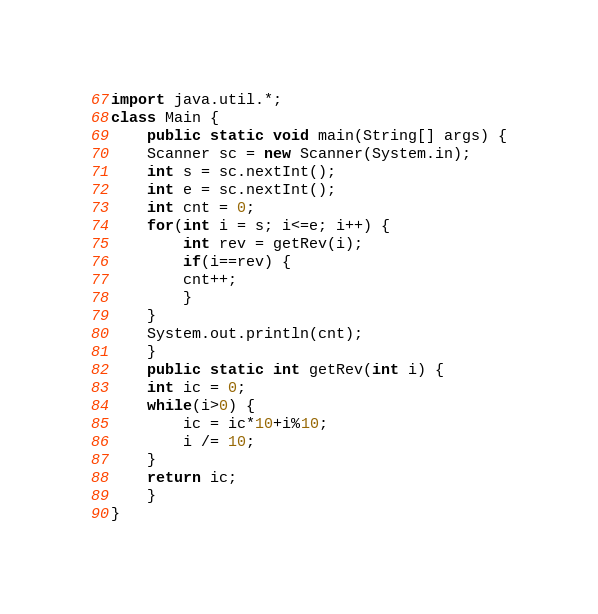Convert code to text. <code><loc_0><loc_0><loc_500><loc_500><_Java_>import java.util.*;
class Main {
    public static void main(String[] args) {
	Scanner sc = new Scanner(System.in);
	int s = sc.nextInt();
	int e = sc.nextInt();
	int cnt = 0;
	for(int i = s; i<=e; i++) {
	    int rev = getRev(i);
	    if(i==rev) {
		cnt++;
	    }
	}
	System.out.println(cnt);
    }
    public static int getRev(int i) {
	int ic = 0;
	while(i>0) {
	    ic = ic*10+i%10;
	    i /= 10;
	}
	return ic;
    }
}</code> 